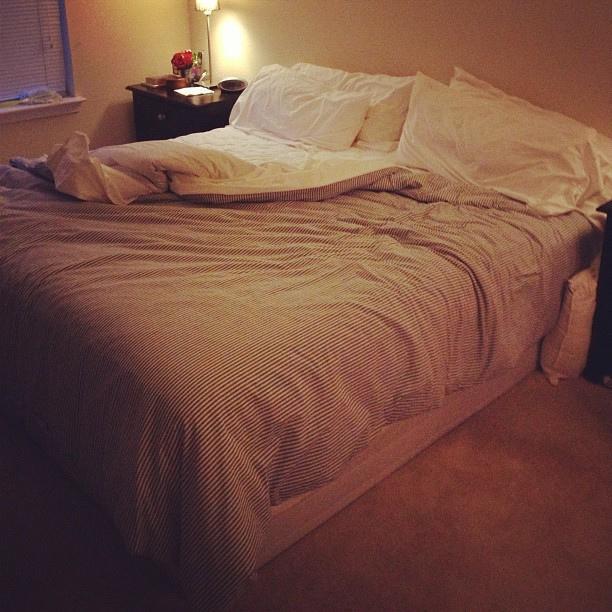How many sources of light are available?
Give a very brief answer. 1. How many lamps can you see?
Give a very brief answer. 1. How many people in either image are playing tennis?
Give a very brief answer. 0. 